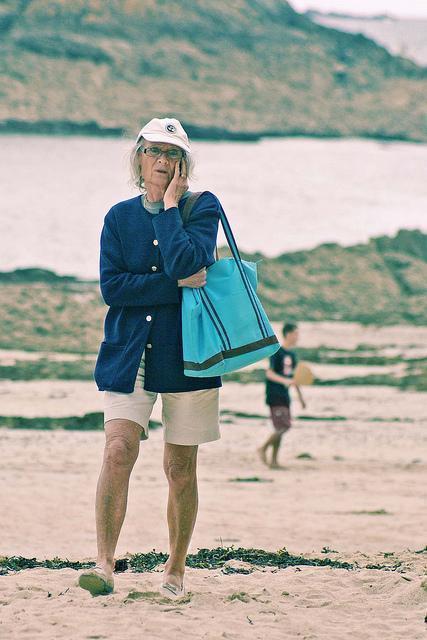What is the old woman doing?
From the following set of four choices, select the accurate answer to respond to the question.
Options: Itching, using phone, laughing, massaging. Using phone. 